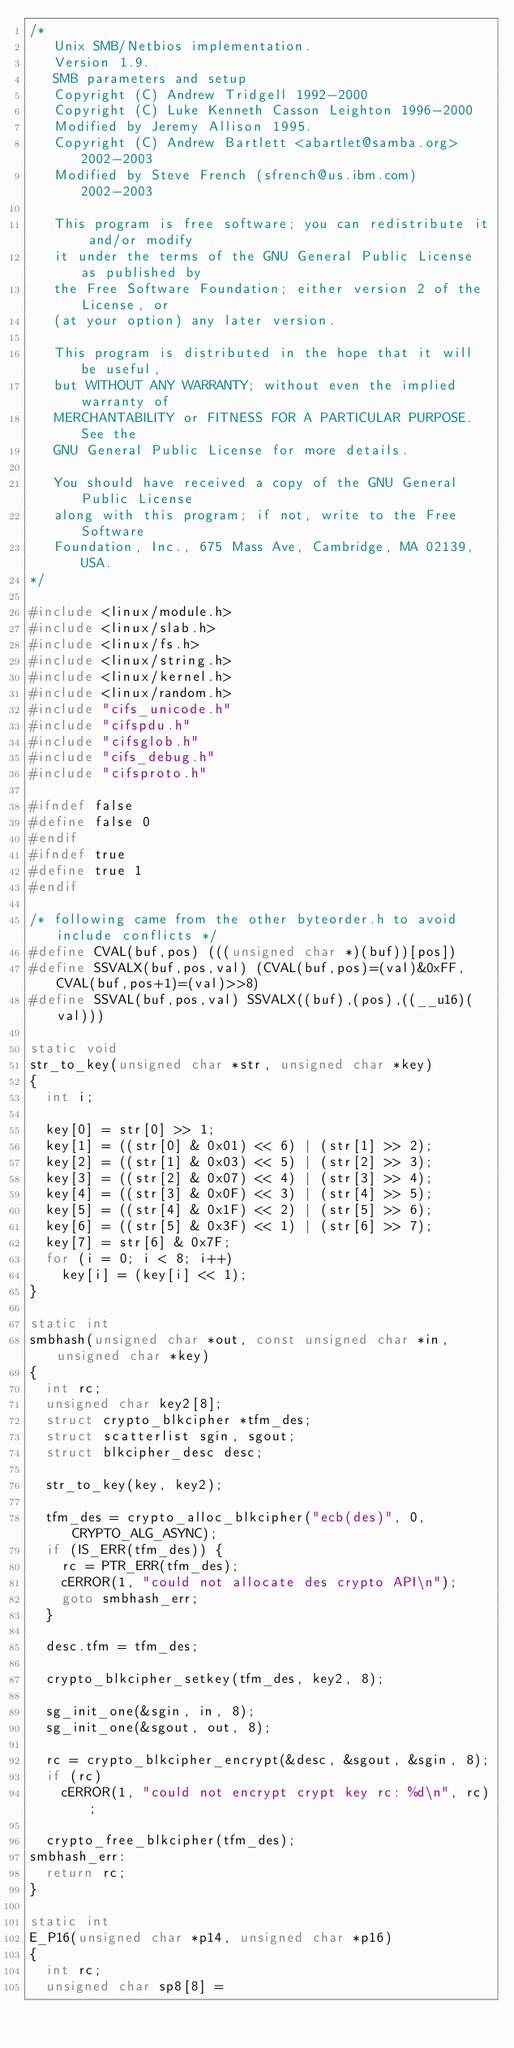<code> <loc_0><loc_0><loc_500><loc_500><_C_>/*
   Unix SMB/Netbios implementation.
   Version 1.9.
   SMB parameters and setup
   Copyright (C) Andrew Tridgell 1992-2000
   Copyright (C) Luke Kenneth Casson Leighton 1996-2000
   Modified by Jeremy Allison 1995.
   Copyright (C) Andrew Bartlett <abartlet@samba.org> 2002-2003
   Modified by Steve French (sfrench@us.ibm.com) 2002-2003

   This program is free software; you can redistribute it and/or modify
   it under the terms of the GNU General Public License as published by
   the Free Software Foundation; either version 2 of the License, or
   (at your option) any later version.

   This program is distributed in the hope that it will be useful,
   but WITHOUT ANY WARRANTY; without even the implied warranty of
   MERCHANTABILITY or FITNESS FOR A PARTICULAR PURPOSE.  See the
   GNU General Public License for more details.

   You should have received a copy of the GNU General Public License
   along with this program; if not, write to the Free Software
   Foundation, Inc., 675 Mass Ave, Cambridge, MA 02139, USA.
*/

#include <linux/module.h>
#include <linux/slab.h>
#include <linux/fs.h>
#include <linux/string.h>
#include <linux/kernel.h>
#include <linux/random.h>
#include "cifs_unicode.h"
#include "cifspdu.h"
#include "cifsglob.h"
#include "cifs_debug.h"
#include "cifsproto.h"

#ifndef false
#define false 0
#endif
#ifndef true
#define true 1
#endif

/* following came from the other byteorder.h to avoid include conflicts */
#define CVAL(buf,pos) (((unsigned char *)(buf))[pos])
#define SSVALX(buf,pos,val) (CVAL(buf,pos)=(val)&0xFF,CVAL(buf,pos+1)=(val)>>8)
#define SSVAL(buf,pos,val) SSVALX((buf),(pos),((__u16)(val)))

static void
str_to_key(unsigned char *str, unsigned char *key)
{
	int i;

	key[0] = str[0] >> 1;
	key[1] = ((str[0] & 0x01) << 6) | (str[1] >> 2);
	key[2] = ((str[1] & 0x03) << 5) | (str[2] >> 3);
	key[3] = ((str[2] & 0x07) << 4) | (str[3] >> 4);
	key[4] = ((str[3] & 0x0F) << 3) | (str[4] >> 5);
	key[5] = ((str[4] & 0x1F) << 2) | (str[5] >> 6);
	key[6] = ((str[5] & 0x3F) << 1) | (str[6] >> 7);
	key[7] = str[6] & 0x7F;
	for (i = 0; i < 8; i++)
		key[i] = (key[i] << 1);
}

static int
smbhash(unsigned char *out, const unsigned char *in, unsigned char *key)
{
	int rc;
	unsigned char key2[8];
	struct crypto_blkcipher *tfm_des;
	struct scatterlist sgin, sgout;
	struct blkcipher_desc desc;

	str_to_key(key, key2);

	tfm_des = crypto_alloc_blkcipher("ecb(des)", 0, CRYPTO_ALG_ASYNC);
	if (IS_ERR(tfm_des)) {
		rc = PTR_ERR(tfm_des);
		cERROR(1, "could not allocate des crypto API\n");
		goto smbhash_err;
	}

	desc.tfm = tfm_des;

	crypto_blkcipher_setkey(tfm_des, key2, 8);

	sg_init_one(&sgin, in, 8);
	sg_init_one(&sgout, out, 8);

	rc = crypto_blkcipher_encrypt(&desc, &sgout, &sgin, 8);
	if (rc)
		cERROR(1, "could not encrypt crypt key rc: %d\n", rc);

	crypto_free_blkcipher(tfm_des);
smbhash_err:
	return rc;
}

static int
E_P16(unsigned char *p14, unsigned char *p16)
{
	int rc;
	unsigned char sp8[8] =</code> 